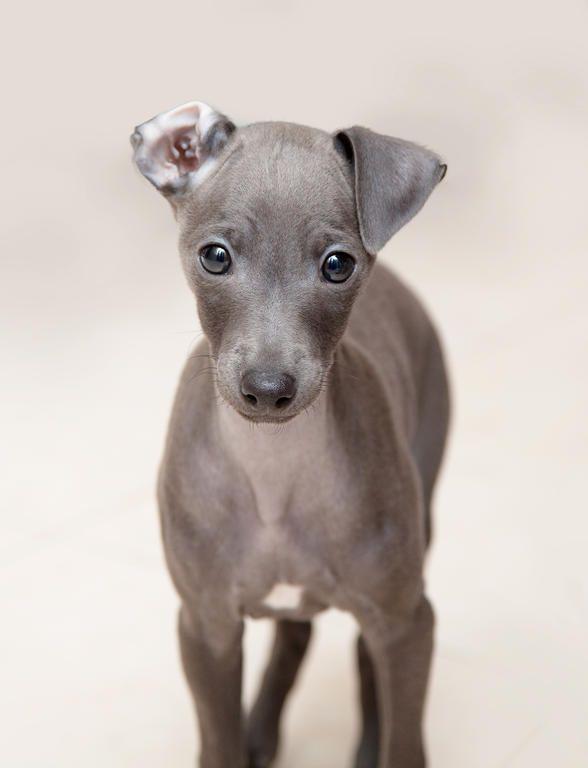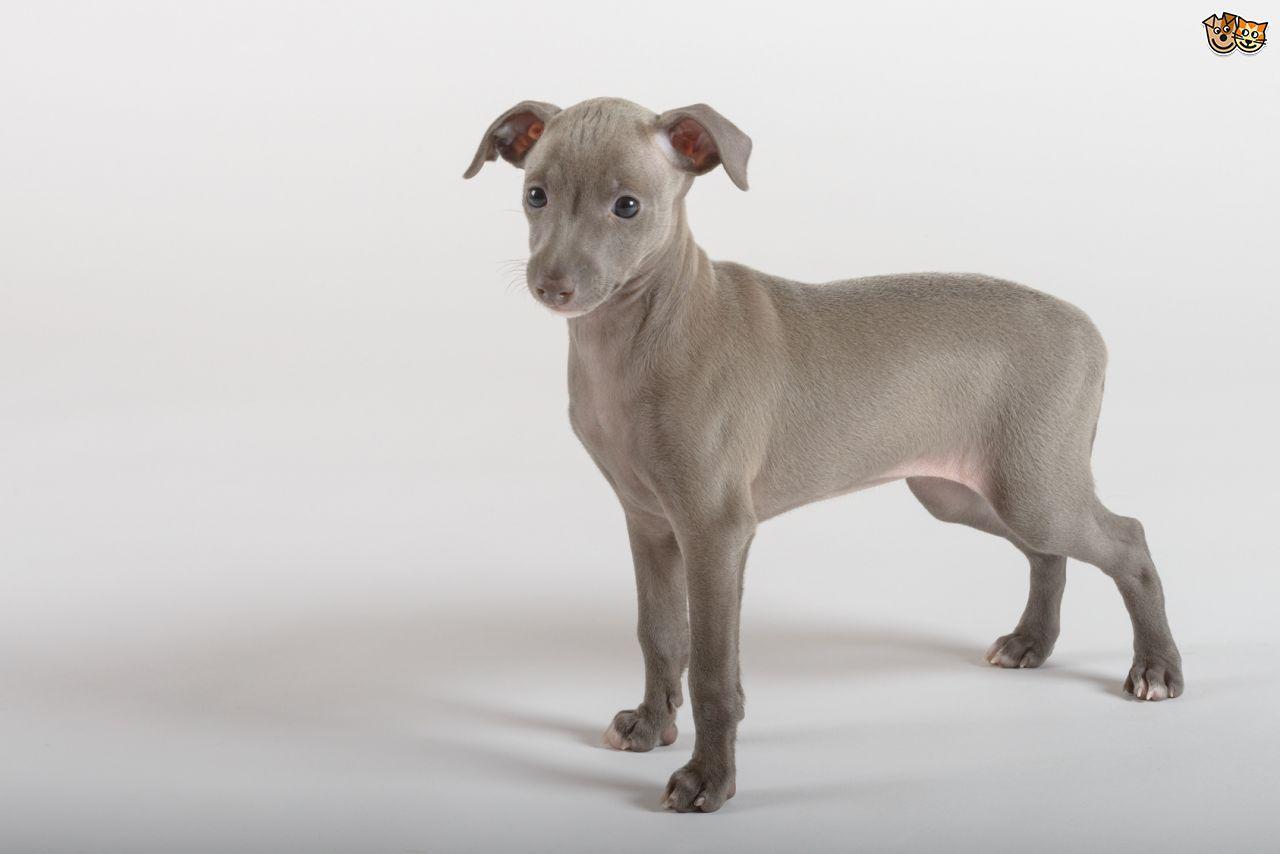The first image is the image on the left, the second image is the image on the right. Analyze the images presented: Is the assertion "the dog in the image on the right is standing on all fours" valid? Answer yes or no. Yes. The first image is the image on the left, the second image is the image on the right. Analyze the images presented: Is the assertion "All images show one dog, with the dog on the right standing indoors." valid? Answer yes or no. Yes. 